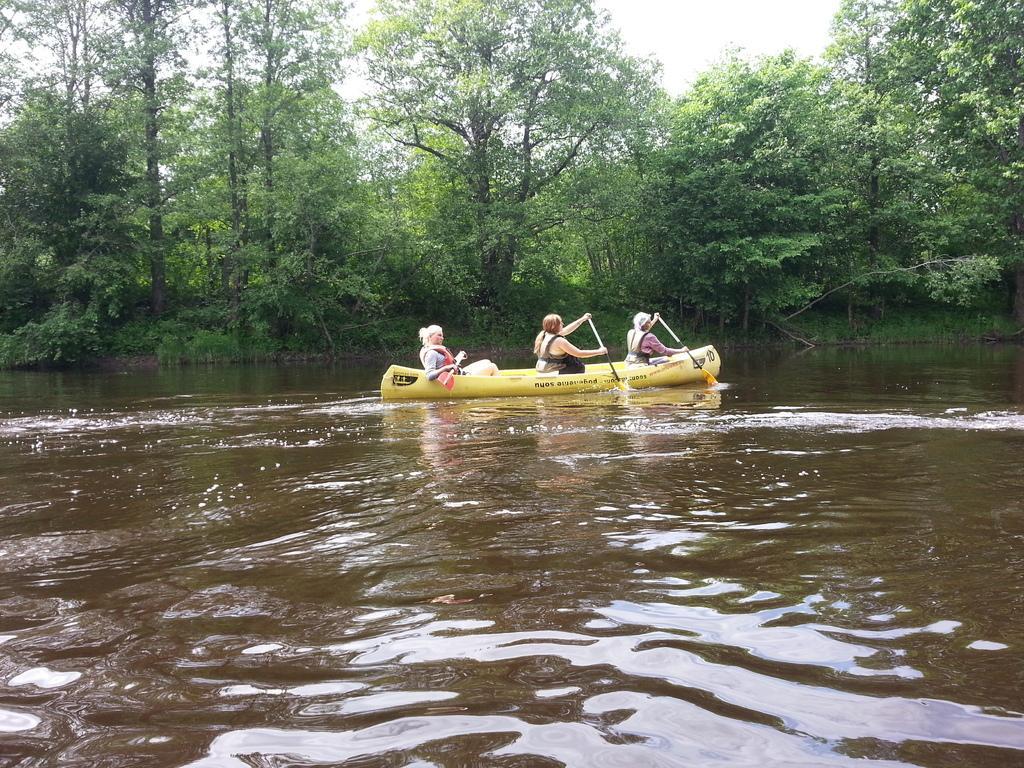Describe this image in one or two sentences. In this picture I can see three people sitting in the boat and holding pedals in their hands and I can see water, trees in the background and a cloudy sky. 